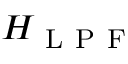<formula> <loc_0><loc_0><loc_500><loc_500>H _ { L P F }</formula> 